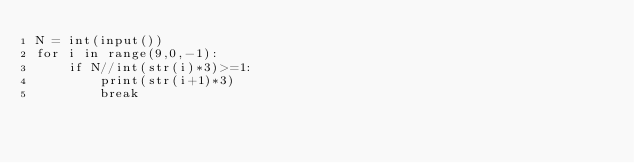<code> <loc_0><loc_0><loc_500><loc_500><_Python_>N = int(input())
for i in range(9,0,-1):
    if N//int(str(i)*3)>=1:
        print(str(i+1)*3)
        break
</code> 